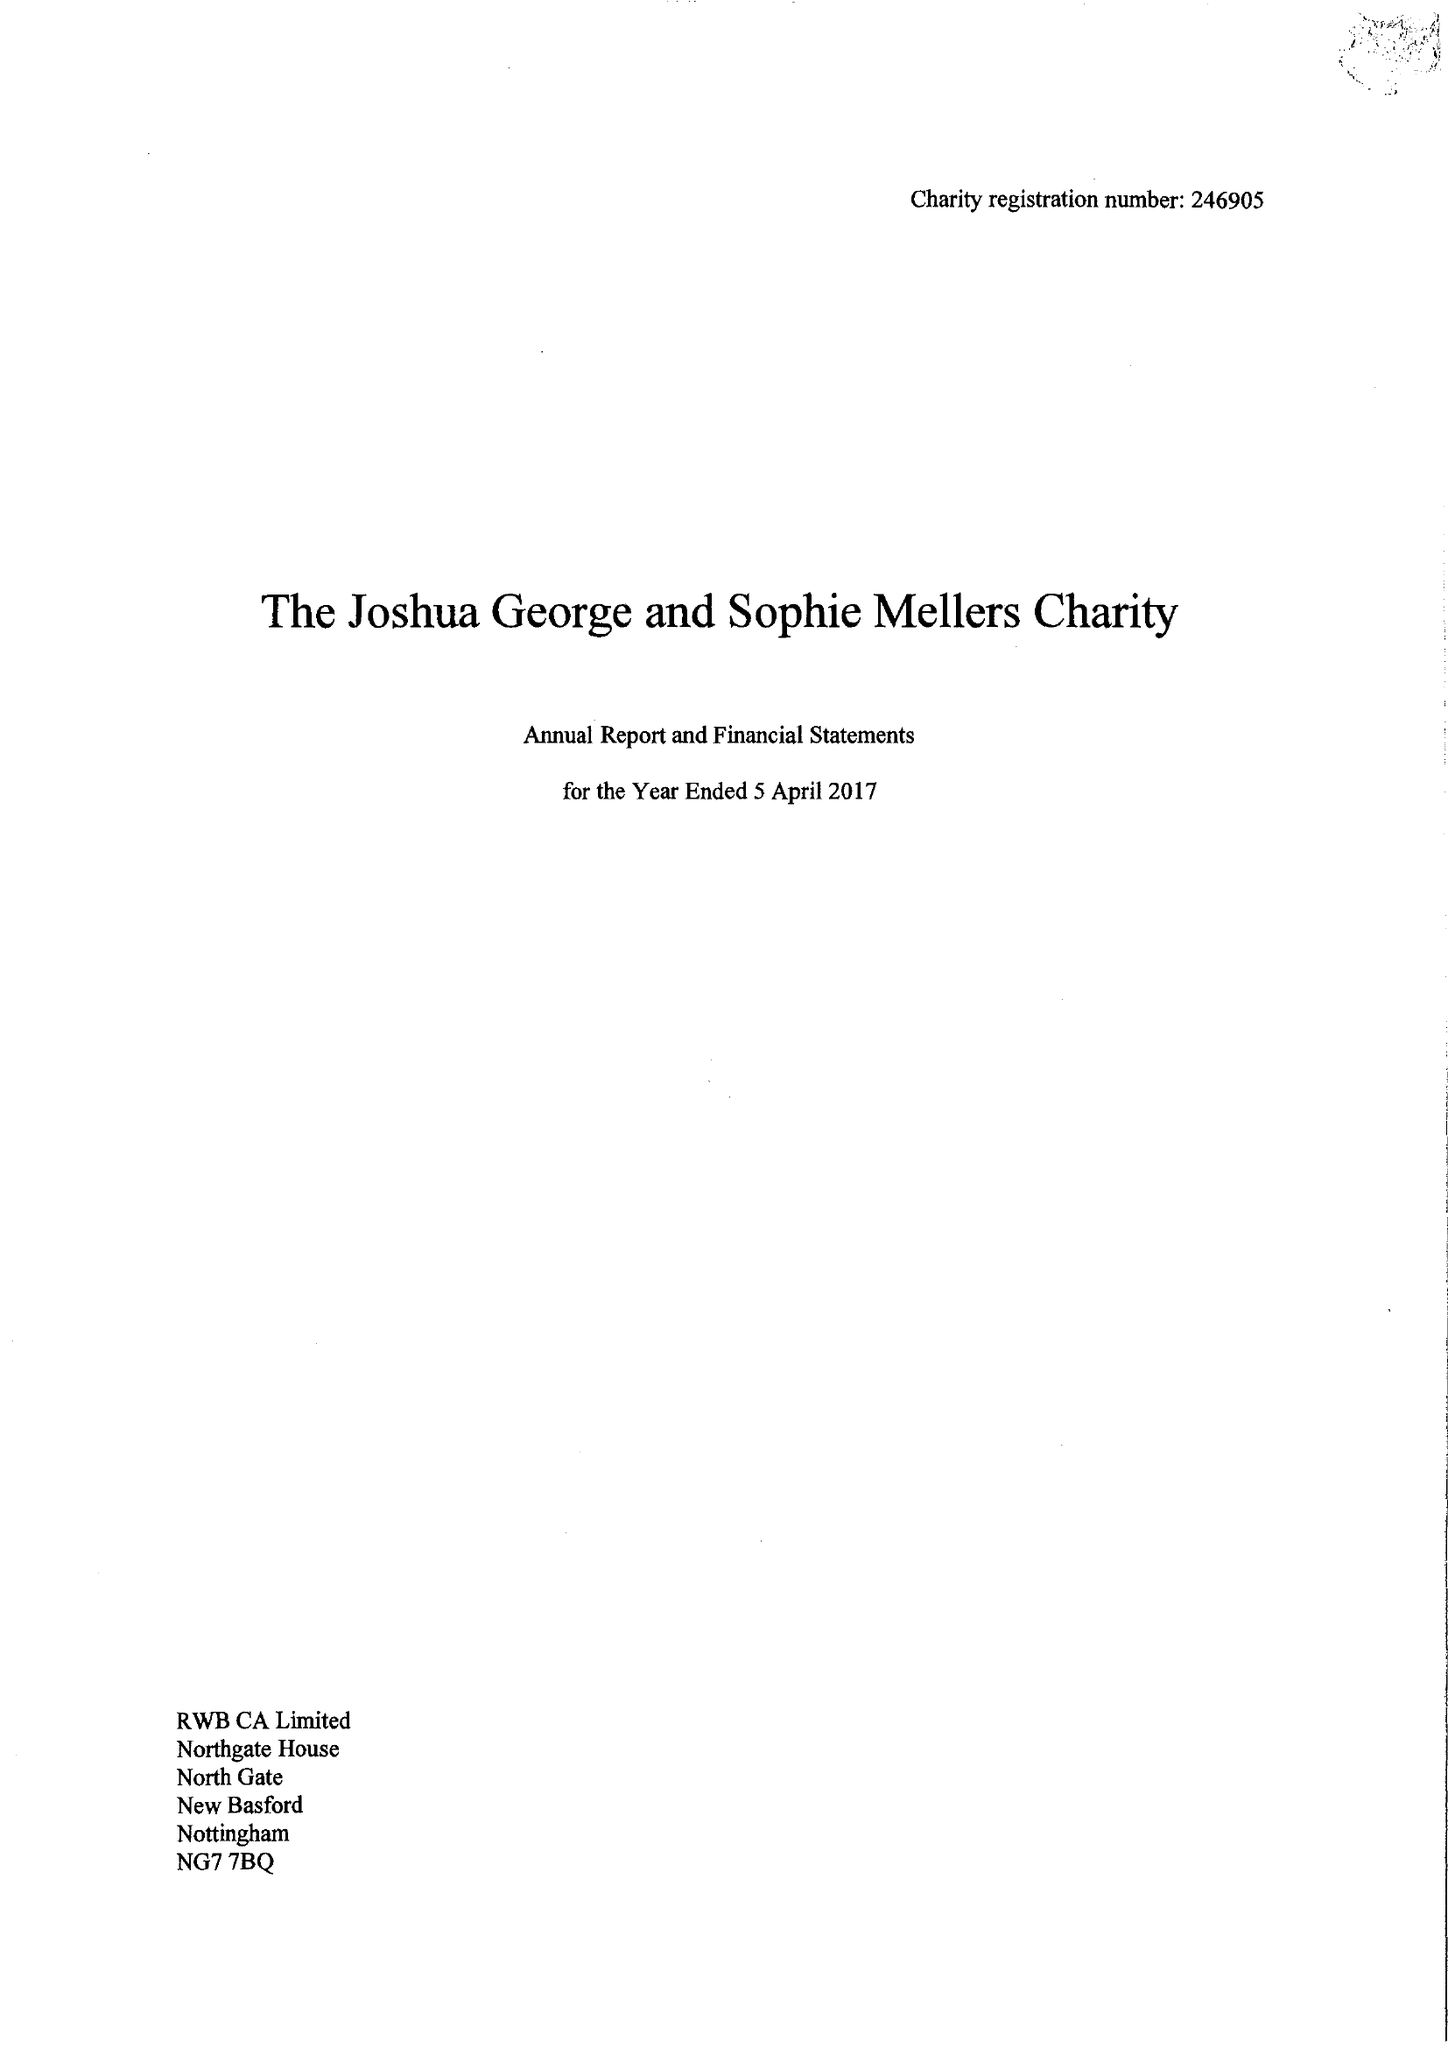What is the value for the address__post_town?
Answer the question using a single word or phrase. NOTTINGHAM 